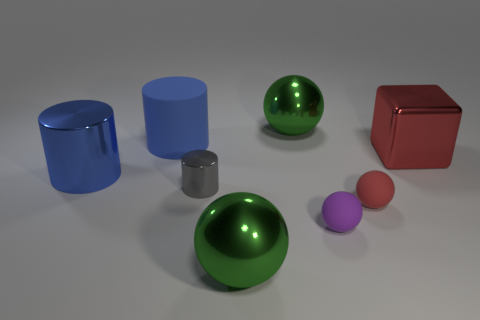Are there more matte cylinders that are in front of the large block than tiny gray cylinders that are behind the tiny gray cylinder?
Make the answer very short. No. Are the big thing that is in front of the small gray thing and the green sphere that is behind the red cube made of the same material?
Make the answer very short. Yes. What is the shape of the gray metal thing that is the same size as the purple ball?
Your response must be concise. Cylinder. Are there any tiny purple objects of the same shape as the blue rubber thing?
Keep it short and to the point. No. Is the color of the metallic thing in front of the tiny purple object the same as the tiny matte sphere to the right of the small purple ball?
Ensure brevity in your answer.  No. There is a big cube; are there any big cubes right of it?
Your answer should be compact. No. What is the material of the large object that is behind the big red metallic block and right of the rubber cylinder?
Offer a very short reply. Metal. Is the material of the small purple sphere that is in front of the red sphere the same as the block?
Your response must be concise. No. What is the material of the tiny cylinder?
Provide a succinct answer. Metal. What size is the green thing in front of the blue metal object?
Offer a terse response. Large. 